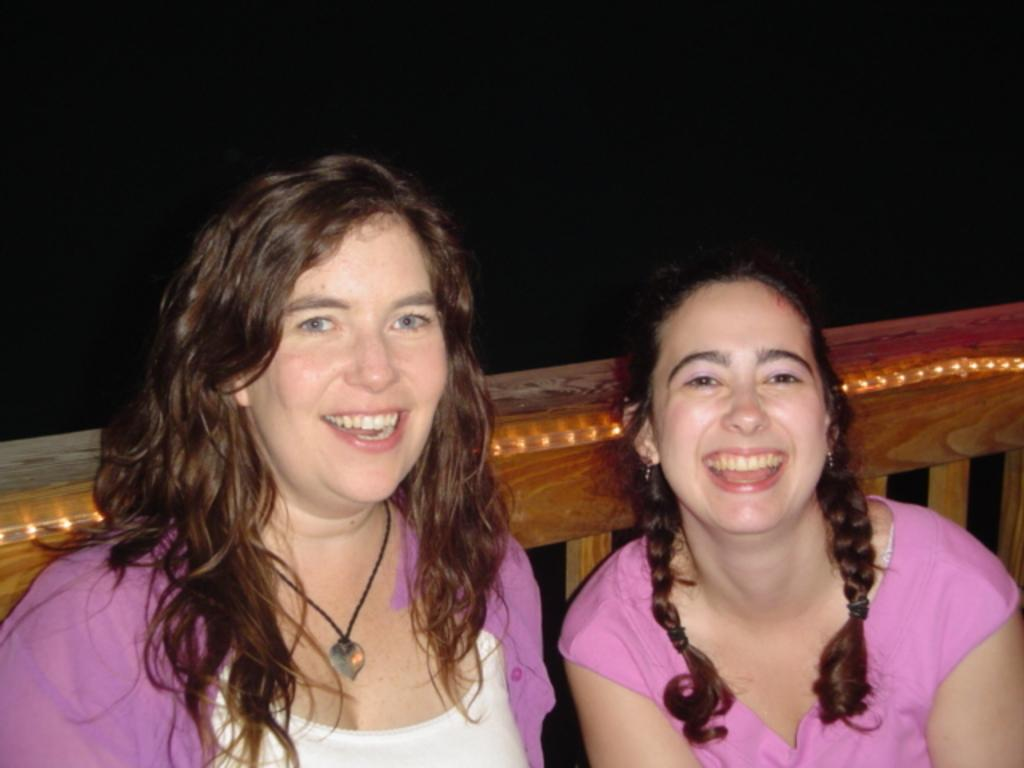Who is present in the image? There is a woman and a girl in the image. What are the woman and the girl doing in the image? Both the woman and the girl are sitting. What expressions do they have? They are both smiling. What are they wearing? The woman and the girl are wearing pink dresses. What can be seen in the background of the image? There is a wooden railing in the background, which is decorated with lights. What type of bun is the woman holding in the image? There is no bun present in the image; the woman and the girl are not holding any food items. What type of cloth is draped over the wooden railing in the image? There is no cloth draped over the wooden railing in the image; it is only decorated with lights. 